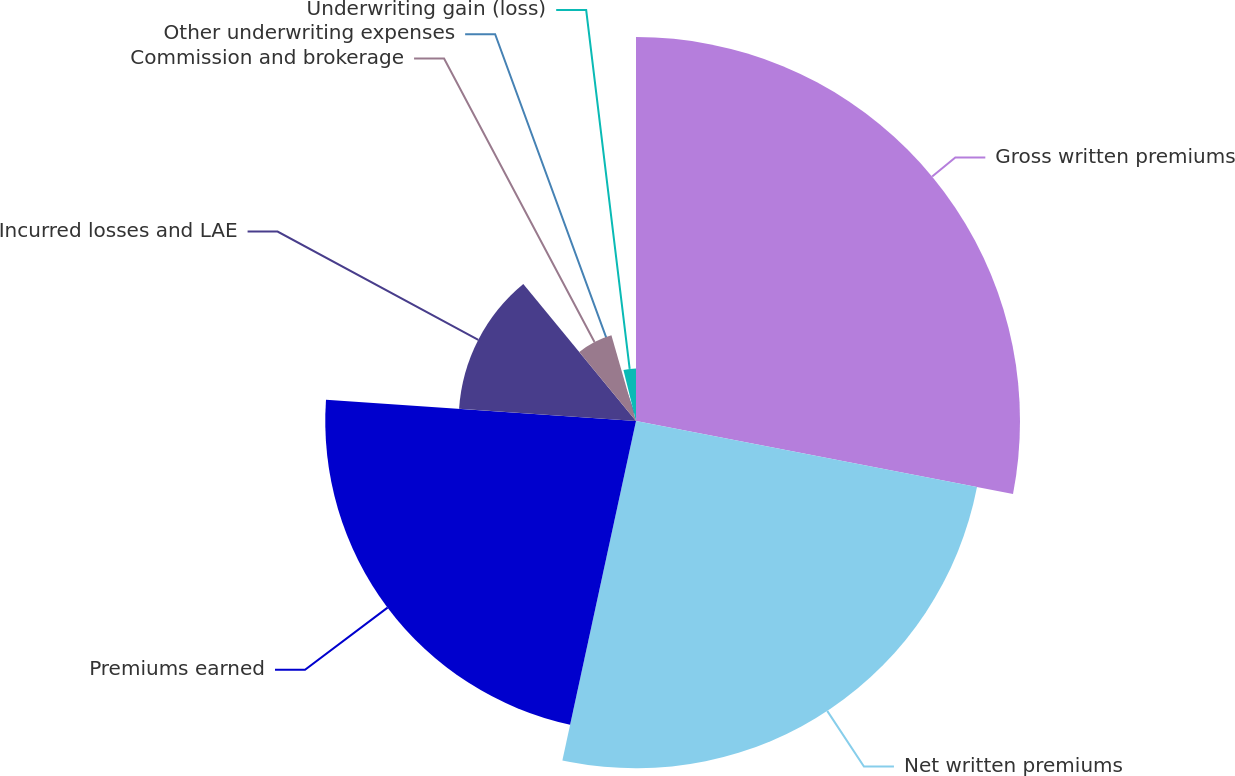Convert chart to OTSL. <chart><loc_0><loc_0><loc_500><loc_500><pie_chart><fcel>Gross written premiums<fcel>Net written premiums<fcel>Premiums earned<fcel>Incurred losses and LAE<fcel>Commission and brokerage<fcel>Other underwriting expenses<fcel>Underwriting gain (loss)<nl><fcel>28.04%<fcel>25.36%<fcel>22.69%<fcel>12.95%<fcel>6.52%<fcel>0.6%<fcel>3.84%<nl></chart> 